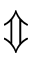<formula> <loc_0><loc_0><loc_500><loc_500>\Updownarrow</formula> 